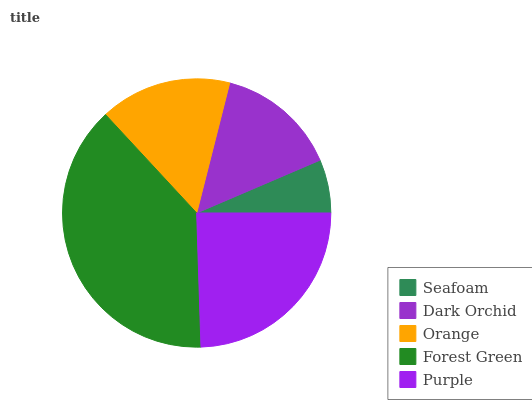Is Seafoam the minimum?
Answer yes or no. Yes. Is Forest Green the maximum?
Answer yes or no. Yes. Is Dark Orchid the minimum?
Answer yes or no. No. Is Dark Orchid the maximum?
Answer yes or no. No. Is Dark Orchid greater than Seafoam?
Answer yes or no. Yes. Is Seafoam less than Dark Orchid?
Answer yes or no. Yes. Is Seafoam greater than Dark Orchid?
Answer yes or no. No. Is Dark Orchid less than Seafoam?
Answer yes or no. No. Is Orange the high median?
Answer yes or no. Yes. Is Orange the low median?
Answer yes or no. Yes. Is Purple the high median?
Answer yes or no. No. Is Forest Green the low median?
Answer yes or no. No. 